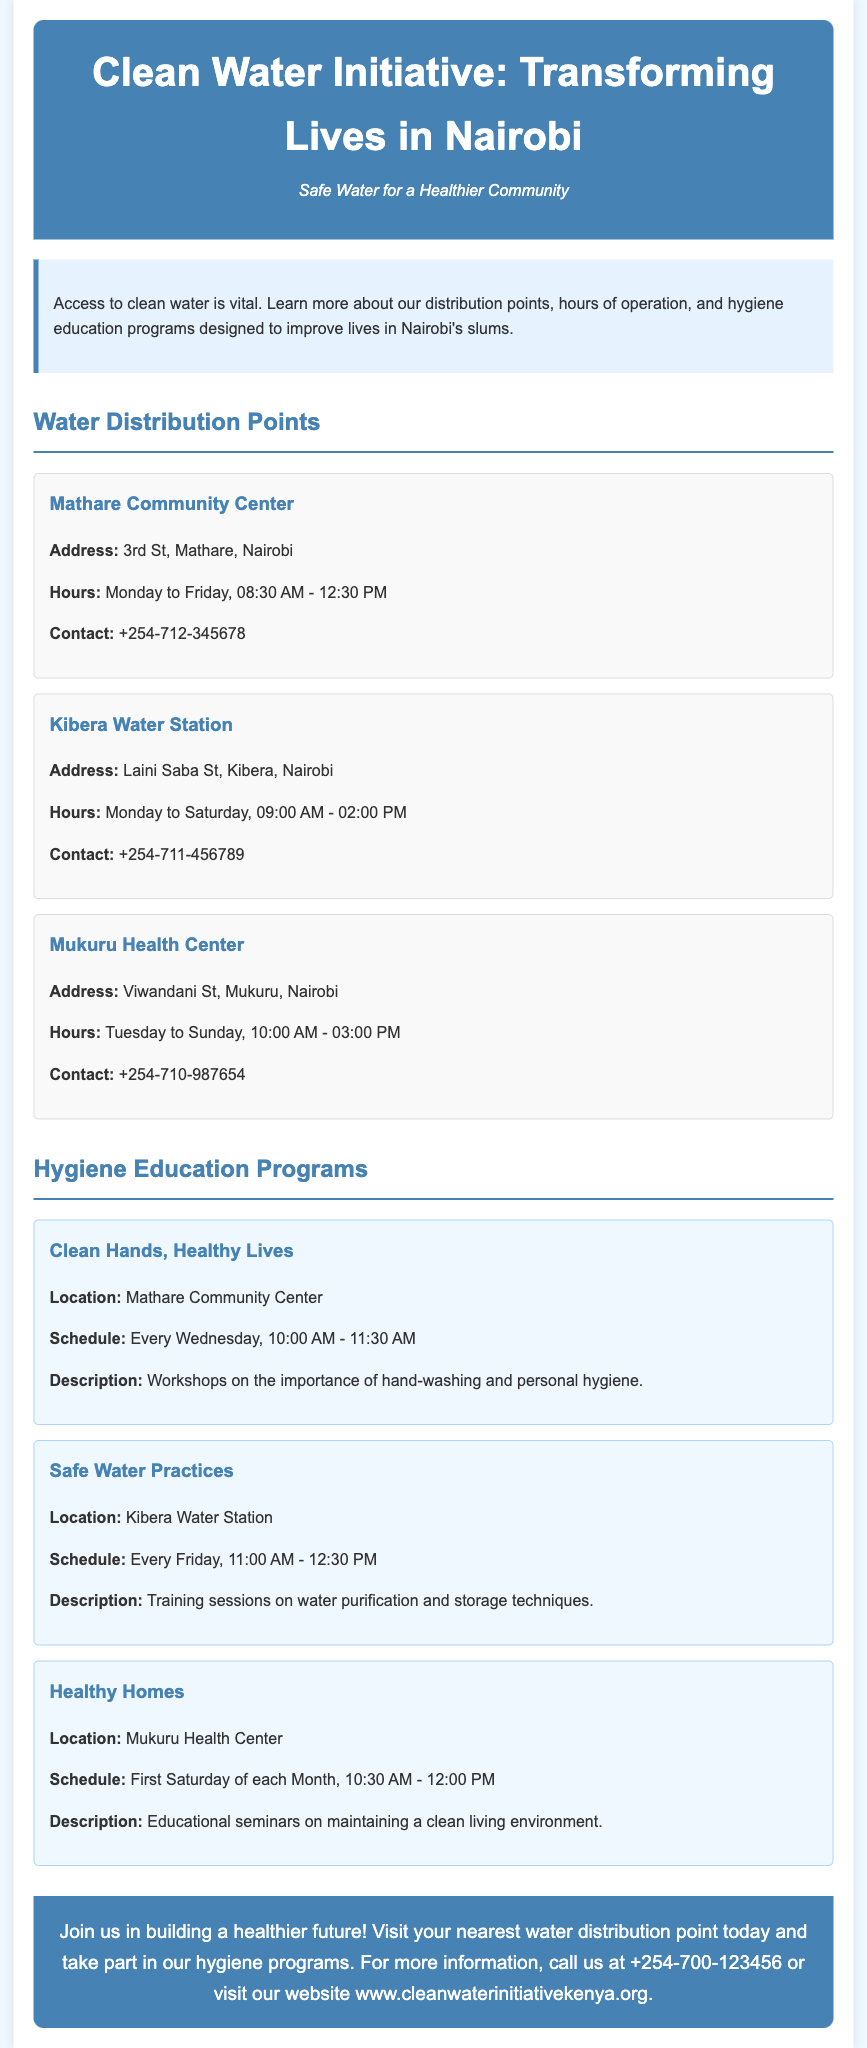What is the address of the Mathare Community Center? The address of the Mathare Community Center is specified in the document as '3rd St, Mathare, Nairobi.'
Answer: 3rd St, Mathare, Nairobi What days is the Kibera Water Station open? The document indicates that the Kibera Water Station operates from Monday to Saturday.
Answer: Monday to Saturday What is the contact number for Mukuru Health Center? The document lists the contact number for Mukuru Health Center as '+254-710-987654.'
Answer: +254-710-987654 When is the "Clean Hands, Healthy Lives" program scheduled? The document states that the "Clean Hands, Healthy Lives" program occurs every Wednesday, from 10:00 AM to 11:30 AM.
Answer: Every Wednesday, 10:00 AM - 11:30 AM What is the objective of the "Safe Water Practices" training? The document describes that the training session focuses on water purification and storage techniques.
Answer: Water purification and storage techniques Which location hosts the "Healthy Homes" seminar? According to the document, the "Healthy Homes" seminar takes place at the Mukuru Health Center.
Answer: Mukuru Health Center How many days a week is the Mathare Community Center open? The document states that the Mathare Community Center is open five days a week.
Answer: Five days What is the phone number for more information on the Clean Water Initiative? The document mentions that for more information, one can call +254-700-123456.
Answer: +254-700-123456 When does the "Healthy Homes" program occur? The document specifies that the "Healthy Homes" program is held on the first Saturday of each month, from 10:30 AM to 12:00 PM.
Answer: First Saturday of each Month, 10:30 AM - 12:00 PM 